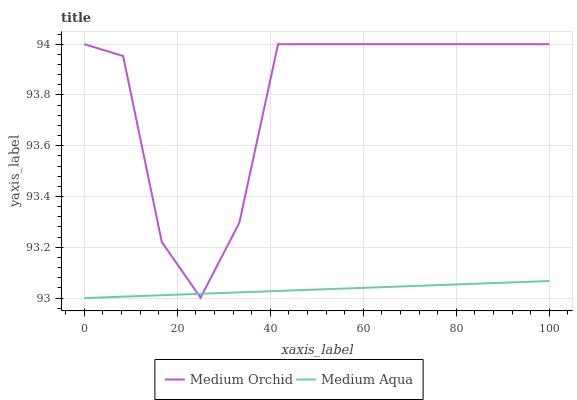Does Medium Aqua have the minimum area under the curve?
Answer yes or no. Yes. Does Medium Orchid have the maximum area under the curve?
Answer yes or no. Yes. Does Medium Aqua have the maximum area under the curve?
Answer yes or no. No. Is Medium Aqua the smoothest?
Answer yes or no. Yes. Is Medium Orchid the roughest?
Answer yes or no. Yes. Is Medium Aqua the roughest?
Answer yes or no. No. Does Medium Aqua have the highest value?
Answer yes or no. No. 